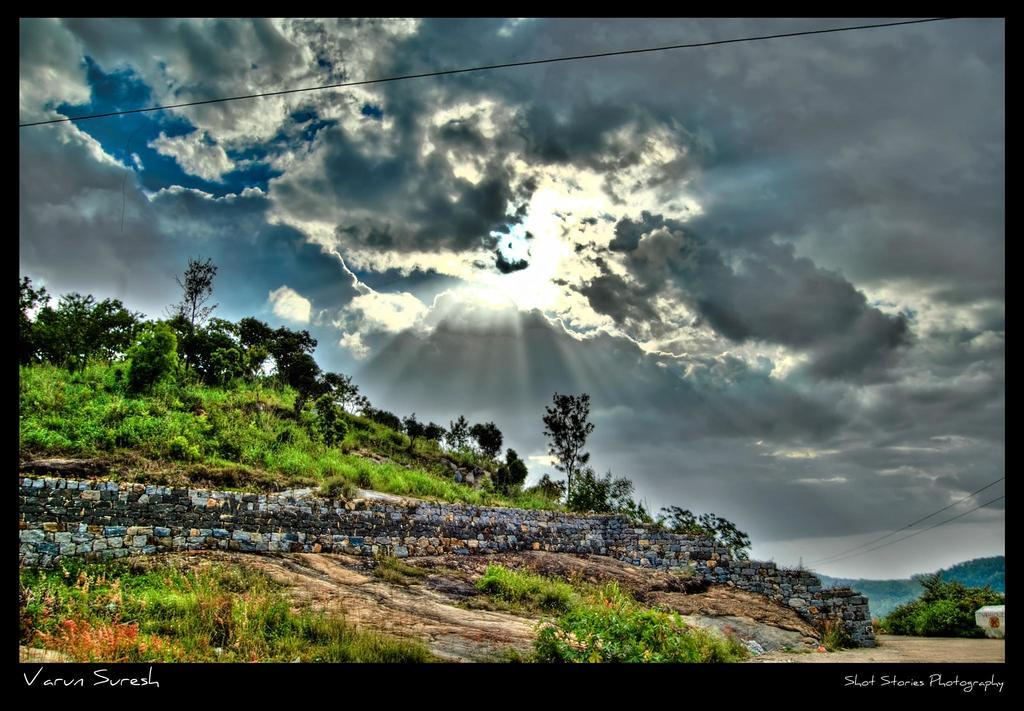What type of vegetation can be seen in the image? There are trees and plants in the image. How would you describe the sky in the image? The sky is blue and cloudy in the image. Are there any words or phrases in the image? Yes, there is text at the bottom left corner and the bottom right corner of the image. Can you hear the family's laughter in the image? There is no sound or audio in the image, so it is not possible to hear any laughter or other sounds. What advice does the grandfather give in the image? There is no grandfather or any dialogue present in the image. 